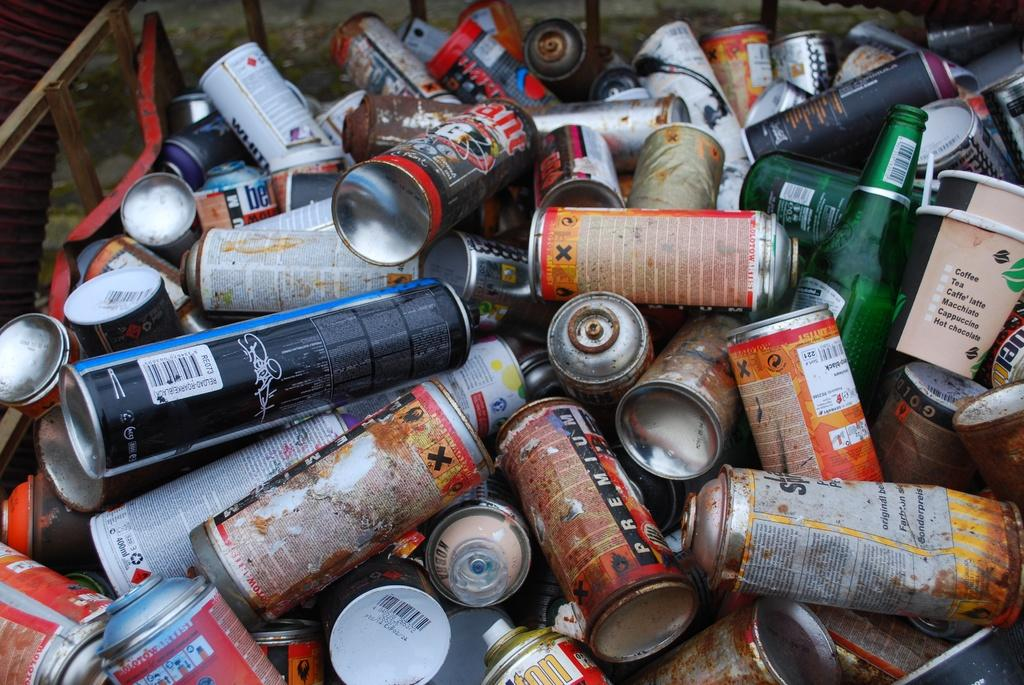What types of containers are visible in the image? There is a group of tins and a group of bottles in the image. Where are the tins and bottles located? The tins and bottles are placed on a surface in the image. What other objects can be seen in the image? There are metal poles in the image. Is there a sink visible in the image? No, there is no sink present in the image. What type of relation exists between the tins and bottles in the image? The tins and bottles are separate objects in the image and do not have a direct relation to each other. 